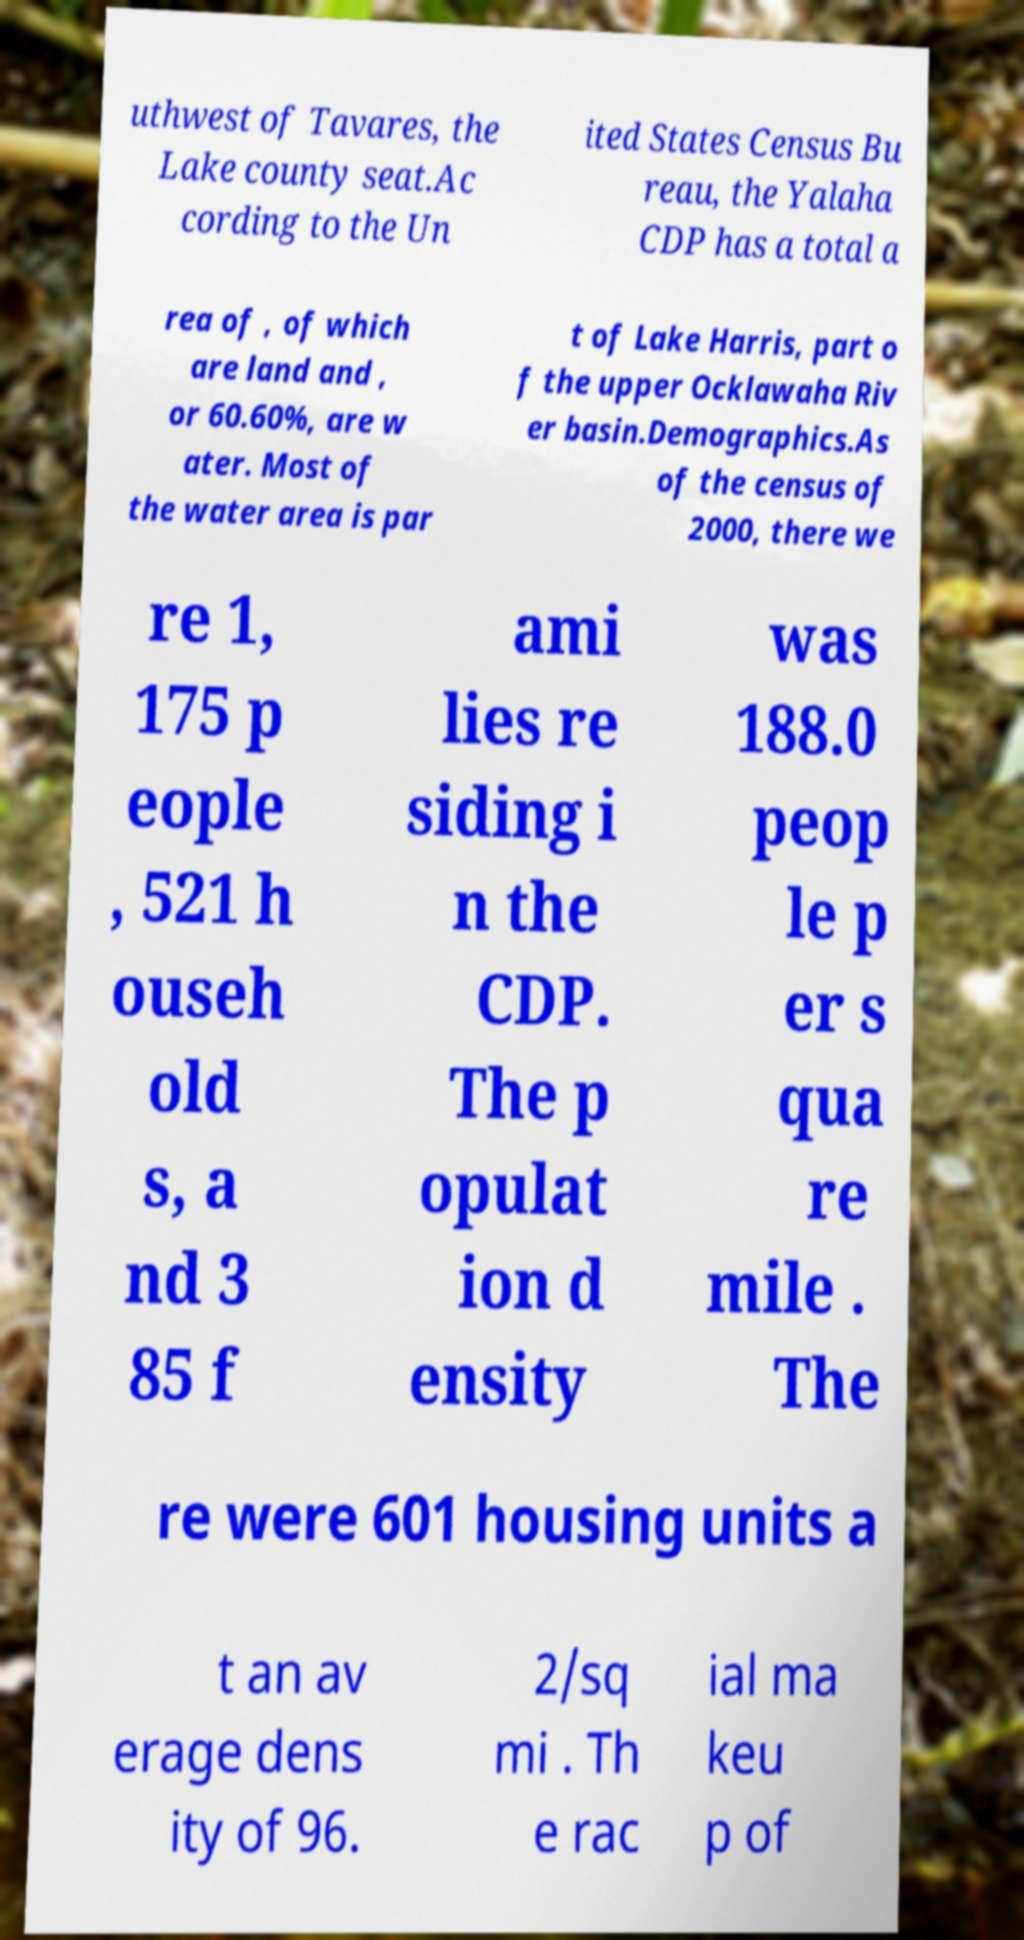Please identify and transcribe the text found in this image. uthwest of Tavares, the Lake county seat.Ac cording to the Un ited States Census Bu reau, the Yalaha CDP has a total a rea of , of which are land and , or 60.60%, are w ater. Most of the water area is par t of Lake Harris, part o f the upper Ocklawaha Riv er basin.Demographics.As of the census of 2000, there we re 1, 175 p eople , 521 h ouseh old s, a nd 3 85 f ami lies re siding i n the CDP. The p opulat ion d ensity was 188.0 peop le p er s qua re mile . The re were 601 housing units a t an av erage dens ity of 96. 2/sq mi . Th e rac ial ma keu p of 